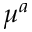Convert formula to latex. <formula><loc_0><loc_0><loc_500><loc_500>\mu ^ { a }</formula> 